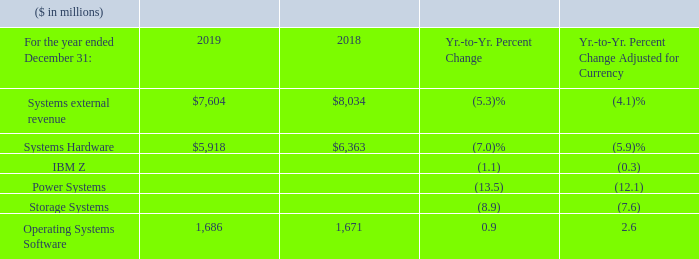Systems revenue of $7,604 million decreased 5.3 percent year to year as reported (4 percent adjusted for currency). Systems Hardware revenue of $5,918 million declined 7.0 percent as reported (6 percent adjusted for currency), driven primarily by declines in Power Systems and Storage Systems. Operating Systems Software revenue of $1,686 million grew 0.9 percent as reported (3 percent adjusted for currency) compared to the prior year.
Within Systems Hardware, IBM Z revenue decreased 1.1 percent as reported but was essentially flat adjusted for currency, reflecting the mainframe product cycles. Revenue declined through the first three quarters due to the end of the z14 product cycle, but there was strong growth in the fourth quarter driven by z15 shipments. The z15’s strong performance demonstrates client demand for technology that offers improved data privacy and resiliency in the hybrid cloud environment.
The z15 mainframe’s capabilities extend the platform’s differentiation with encryption everywhere, cloud-native development and instant recovery. In October, we announced OpenShift for IBM Z, bringing together the industry’s most comprehensive enterprise container and Kubernetes platform with the enterprise server
platforms of IBM Z and LinuxONE. IBM Z continues to deliver a high-value, secure and scalable platform for our clients.
Power Systems revenue decreased 13.5 percent as reported (12 percent adjusted for currency) year to year, due to the strong performance during the second half of 2018 driven by Linux and the introduction of the POWER9-based architecture in our mid-range and high-end products.
Storage Systems revenue decreased 8.9 percent as reported (8 percent adjusted for currency) year to year, with improvements in year-to-year performance in the fourth quarter of 2019, driven primarily by the launch of the next generation high-end storage
system DS8900 in November.
Within Systems, cloud revenue of $2.9 billion declined 4 percent as reported and 3 percent adjusted for currency.
What caused the Systems Hardware revenue to decline? Driven primarily by declines in power systems and storage systems. What caused the IBM Z revenue to decline? Ibm z revenue decreased 1.1 percent as reported but was essentially flat adjusted for currency, reflecting the mainframe product cycles. revenue declined through the first three quarters due to the end of the z14 product cycle, but there was strong growth in the fourth quarter driven by z15 shipments. What caused the Power Systems revenue to decline? Due to the strong performance during the second half of 2018 driven by linux and the introduction of the power9-based architecture in our mid-range and high-end products. What is the average Systems external revenue?
Answer scale should be: million. (7,604 + 8,034) / 2
Answer: 7819. What is the average of Systems Hardware from 2018 to 2019?
Answer scale should be: million. (5,918 + 6,363) / 2
Answer: 6140.5. What is the increase / (decrease) in Operating Systems Software from 2018 to 2019?
Answer scale should be: million. 1,686 - 1,671
Answer: 15. 